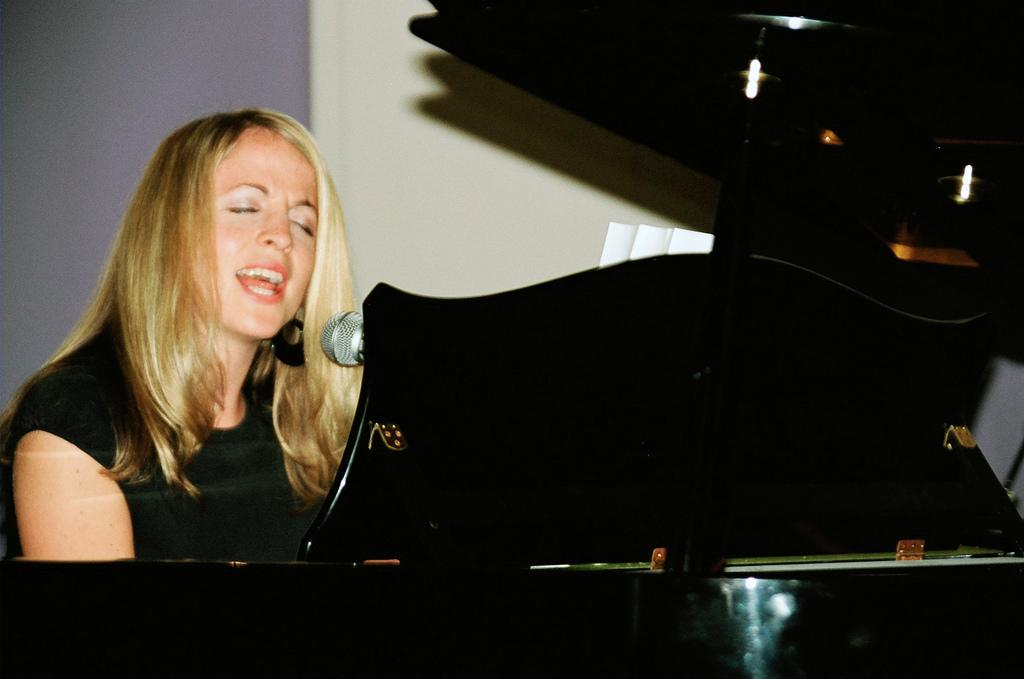What is the woman doing in the image? The woman is playing an instrument and singing. How is the woman amplifying her voice in the image? The woman is using a microphone. What type of polish is the woman applying to her nails in the image? There is no indication in the image that the woman is applying any polish to her nails. 